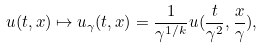<formula> <loc_0><loc_0><loc_500><loc_500>u ( t , x ) \mapsto u _ { \gamma } ( t , x ) = \frac { 1 } { \gamma ^ { 1 / k } } u ( \frac { t } { \gamma ^ { 2 } } , \frac { x } { \gamma } ) ,</formula> 